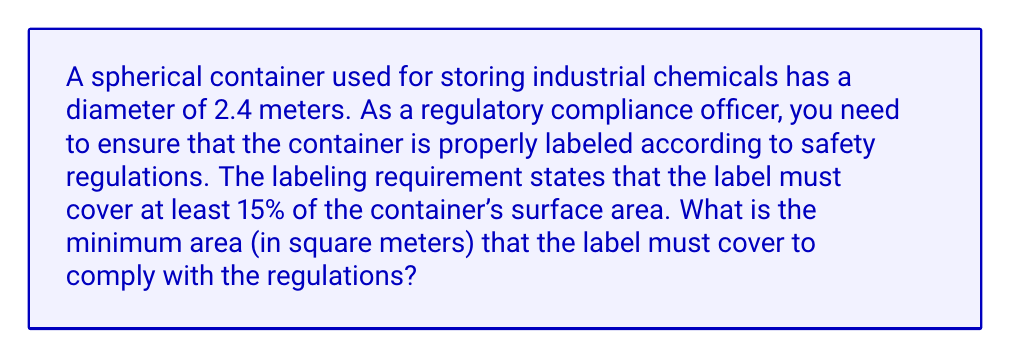Could you help me with this problem? To solve this problem, we need to follow these steps:

1. Calculate the surface area of the spherical container:
   The formula for the surface area of a sphere is $A = 4\pi r^2$, where $r$ is the radius.
   
   Diameter = 2.4 m, so radius = 1.2 m
   
   $$A = 4\pi (1.2 \text{ m})^2 = 4\pi (1.44 \text{ m}^2) = 18.0956 \text{ m}^2$$

2. Calculate 15% of the surface area:
   $$15\% \text{ of } A = 0.15 \times 18.0956 \text{ m}^2 = 2.71434 \text{ m}^2$$

3. Round up to ensure compliance:
   To ensure the label covers at least 15% of the surface area, we round up to 2.72 m².

[asy]
import geometry;

size(200);
draw(circle((0,0),4));
draw((0,0)--(4,0),dashed);
label("r = 1.2 m", (2,0), S);
label("Spherical Container", (0,-5));
[/asy]
Answer: 2.72 m² 